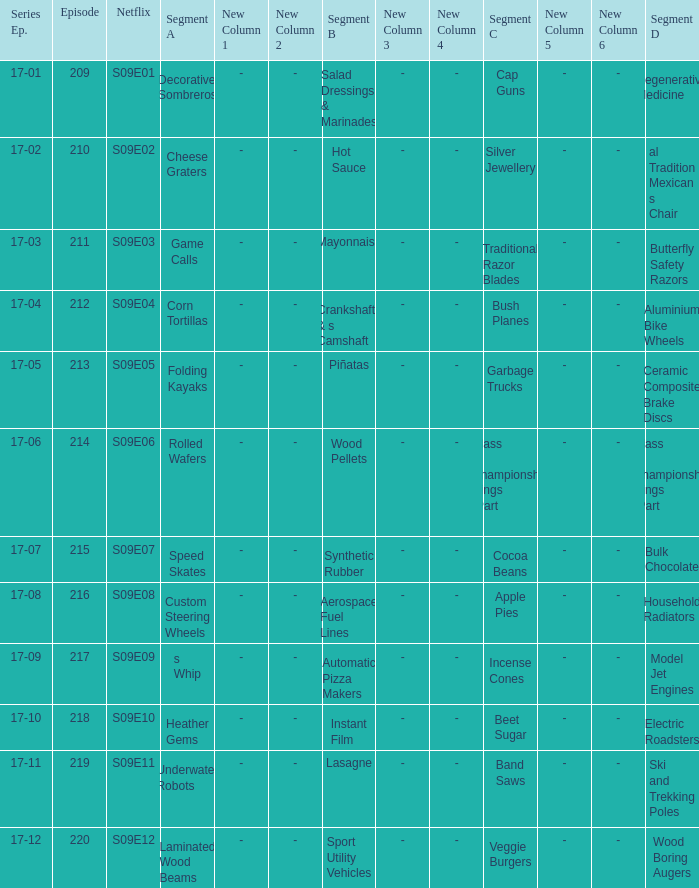For the shows featuring beet sugar, what was on before that Instant Film. 